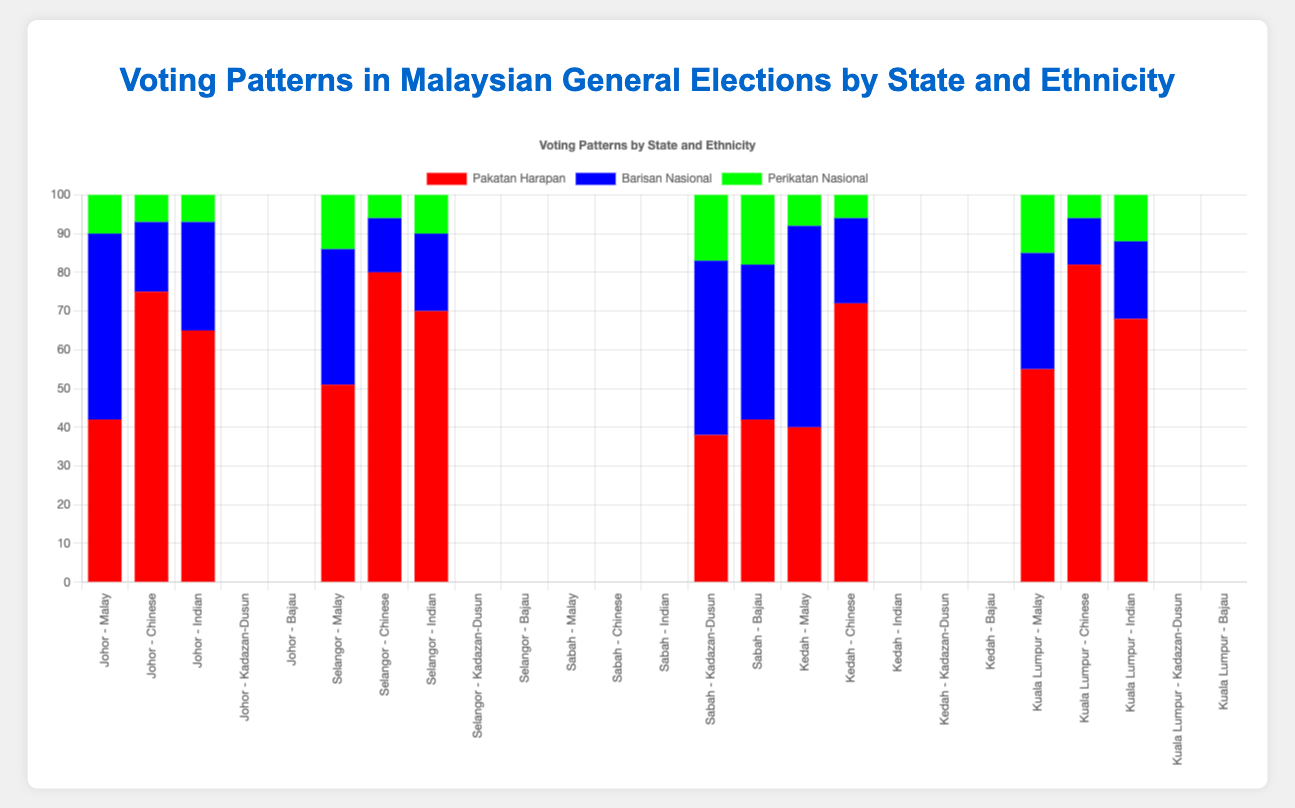Which party received the highest percentage of votes from the Malay ethnic group in Johor? By looking at the bars representing the Malay ethnic group in Johor, the tallest bar corresponds to Barisan Nasional. Thus, Barisan Nasional received the highest percentage of votes from the Malay ethnic group in Johor.
Answer: Barisan Nasional What is the difference in vote percentages between Pakatan Harapan and Barisan Nasional for the Indian ethnic group in Selangor? For the Indian ethnic group in Selangor, Pakatan Harapan received 70% of the votes, while Barisan Nasional received 20%. The difference is 70% - 20% = 50%.
Answer: 50% Among the Chinese ethnic groups in Kuala Lumpur and Kedah, which party received more votes: Pakatan Harapan or Barisan Nasional? In Kuala Lumpur, Pakatan Harapan received 82% and Barisan Nasional 12%. In Kedah, Pakatan Harapan received 72% and Barisan Nasional 22%. Comparing these, Pakatan Harapan received more votes in both states.
Answer: Pakatan Harapan Which ethnic group in Sabah contributed the highest percentage of votes to Perikatan Nasional? By comparing the bars for Perikatan Nasional in Sabah, the Bajau ethnic group has the highest percentage at 18%, compared to the Kadazan-Dusun ethnic group's 17%.
Answer: Bajau Which state had the highest percentage of Pakatan Harapan votes from the Chinese ethnic group? The tallest bar representing Pakatan Harapan votes from the Chinese ethnic group is in Kuala Lumpur, with 82%.
Answer: Kuala Lumpur What is the combined percentage of votes received by Barisan Nasional and Perikatan Nasional from the Kadazan-Dusun ethnic group in Sabah? Barisan Nasional received 45% and Perikatan Nasional received 17% from the Kadazan-Dusun ethnic group in Sabah. The combined percentage is 45% + 17% = 62%.
Answer: 62% Did any party receive more than 50% of the votes from the Indian ethnic group in Selangor? By observing the bars representing the Indian ethnic group in Selangor, Pakatan Harapan received 70%, which is more than 50%.
Answer: Yes Compare the Pakatan Harapan vote percentages from the Malay ethnic group between Johor and Kedah. Which is higher? In Johor, Pakatan Harapan received 42% of the Malay votes, while in Kedah, they received 40%. Hence, Johor has a higher percentage.
Answer: Johor For the Malay ethnic group in Selangor, which two parties together received exactly 65% of the votes? In Selangor, the Malay votes for Pakatan Harapan were 51% and for Perikatan Nasional were 14%. 51% + 14% = 65%.
Answer: Pakatan Harapan and Perikatan Nasional 